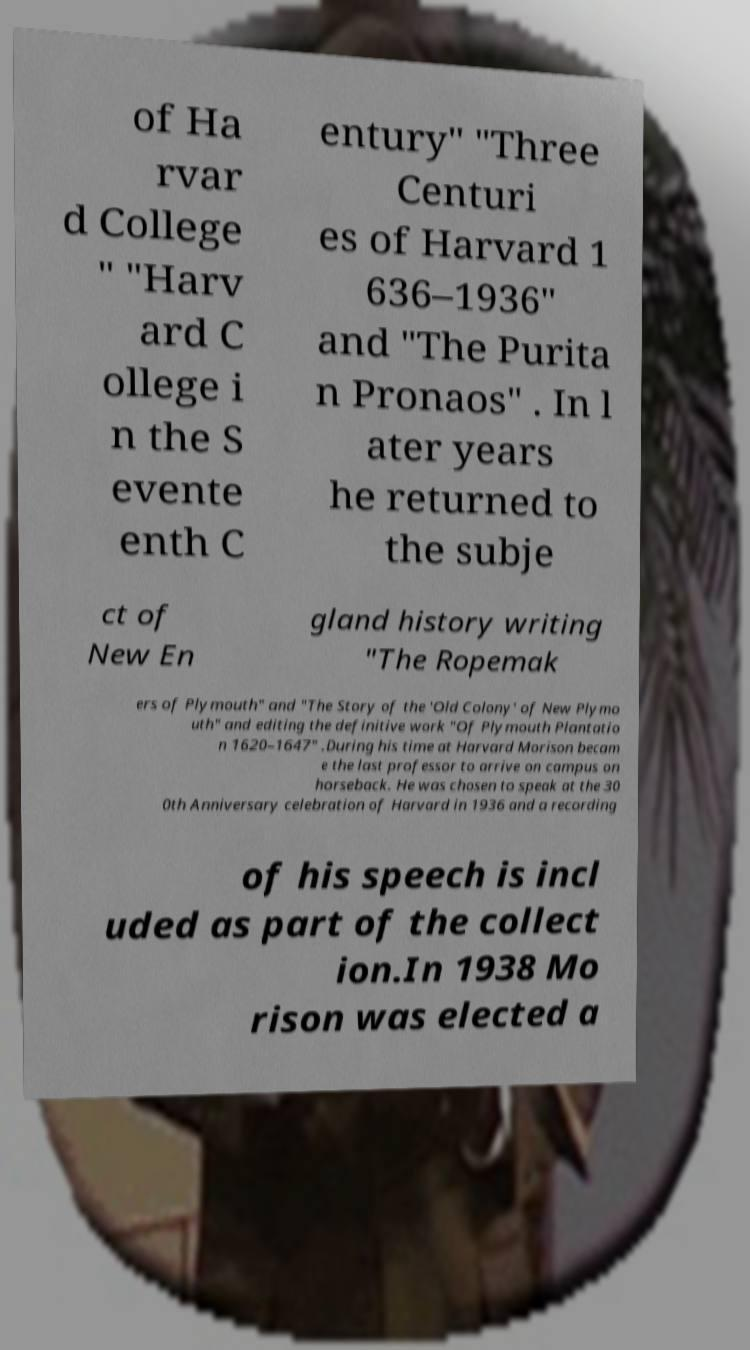Please identify and transcribe the text found in this image. of Ha rvar d College " "Harv ard C ollege i n the S evente enth C entury" "Three Centuri es of Harvard 1 636–1936" and "The Purita n Pronaos" . In l ater years he returned to the subje ct of New En gland history writing "The Ropemak ers of Plymouth" and "The Story of the 'Old Colony' of New Plymo uth" and editing the definitive work "Of Plymouth Plantatio n 1620–1647" .During his time at Harvard Morison becam e the last professor to arrive on campus on horseback. He was chosen to speak at the 30 0th Anniversary celebration of Harvard in 1936 and a recording of his speech is incl uded as part of the collect ion.In 1938 Mo rison was elected a 